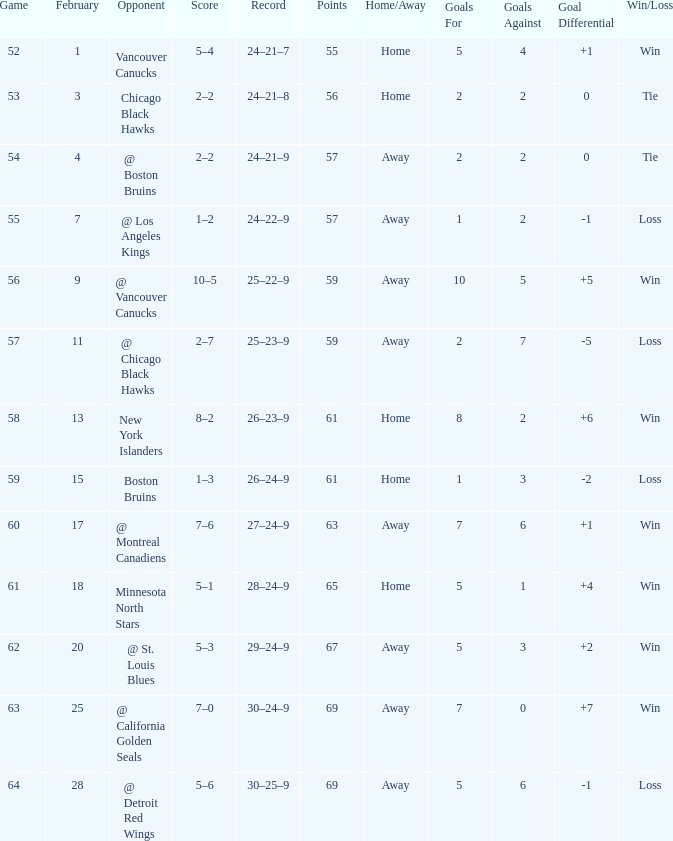How many games have a record of 30–25–9 and more points than 69? 0.0. 